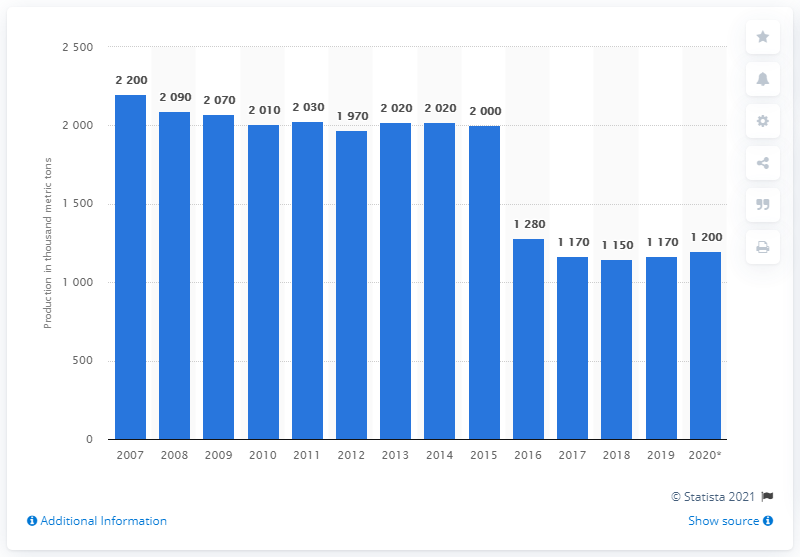Indicate a few pertinent items in this graphic. In 2020, the total production of asbestos dropped to 1.2 million metric tons. 